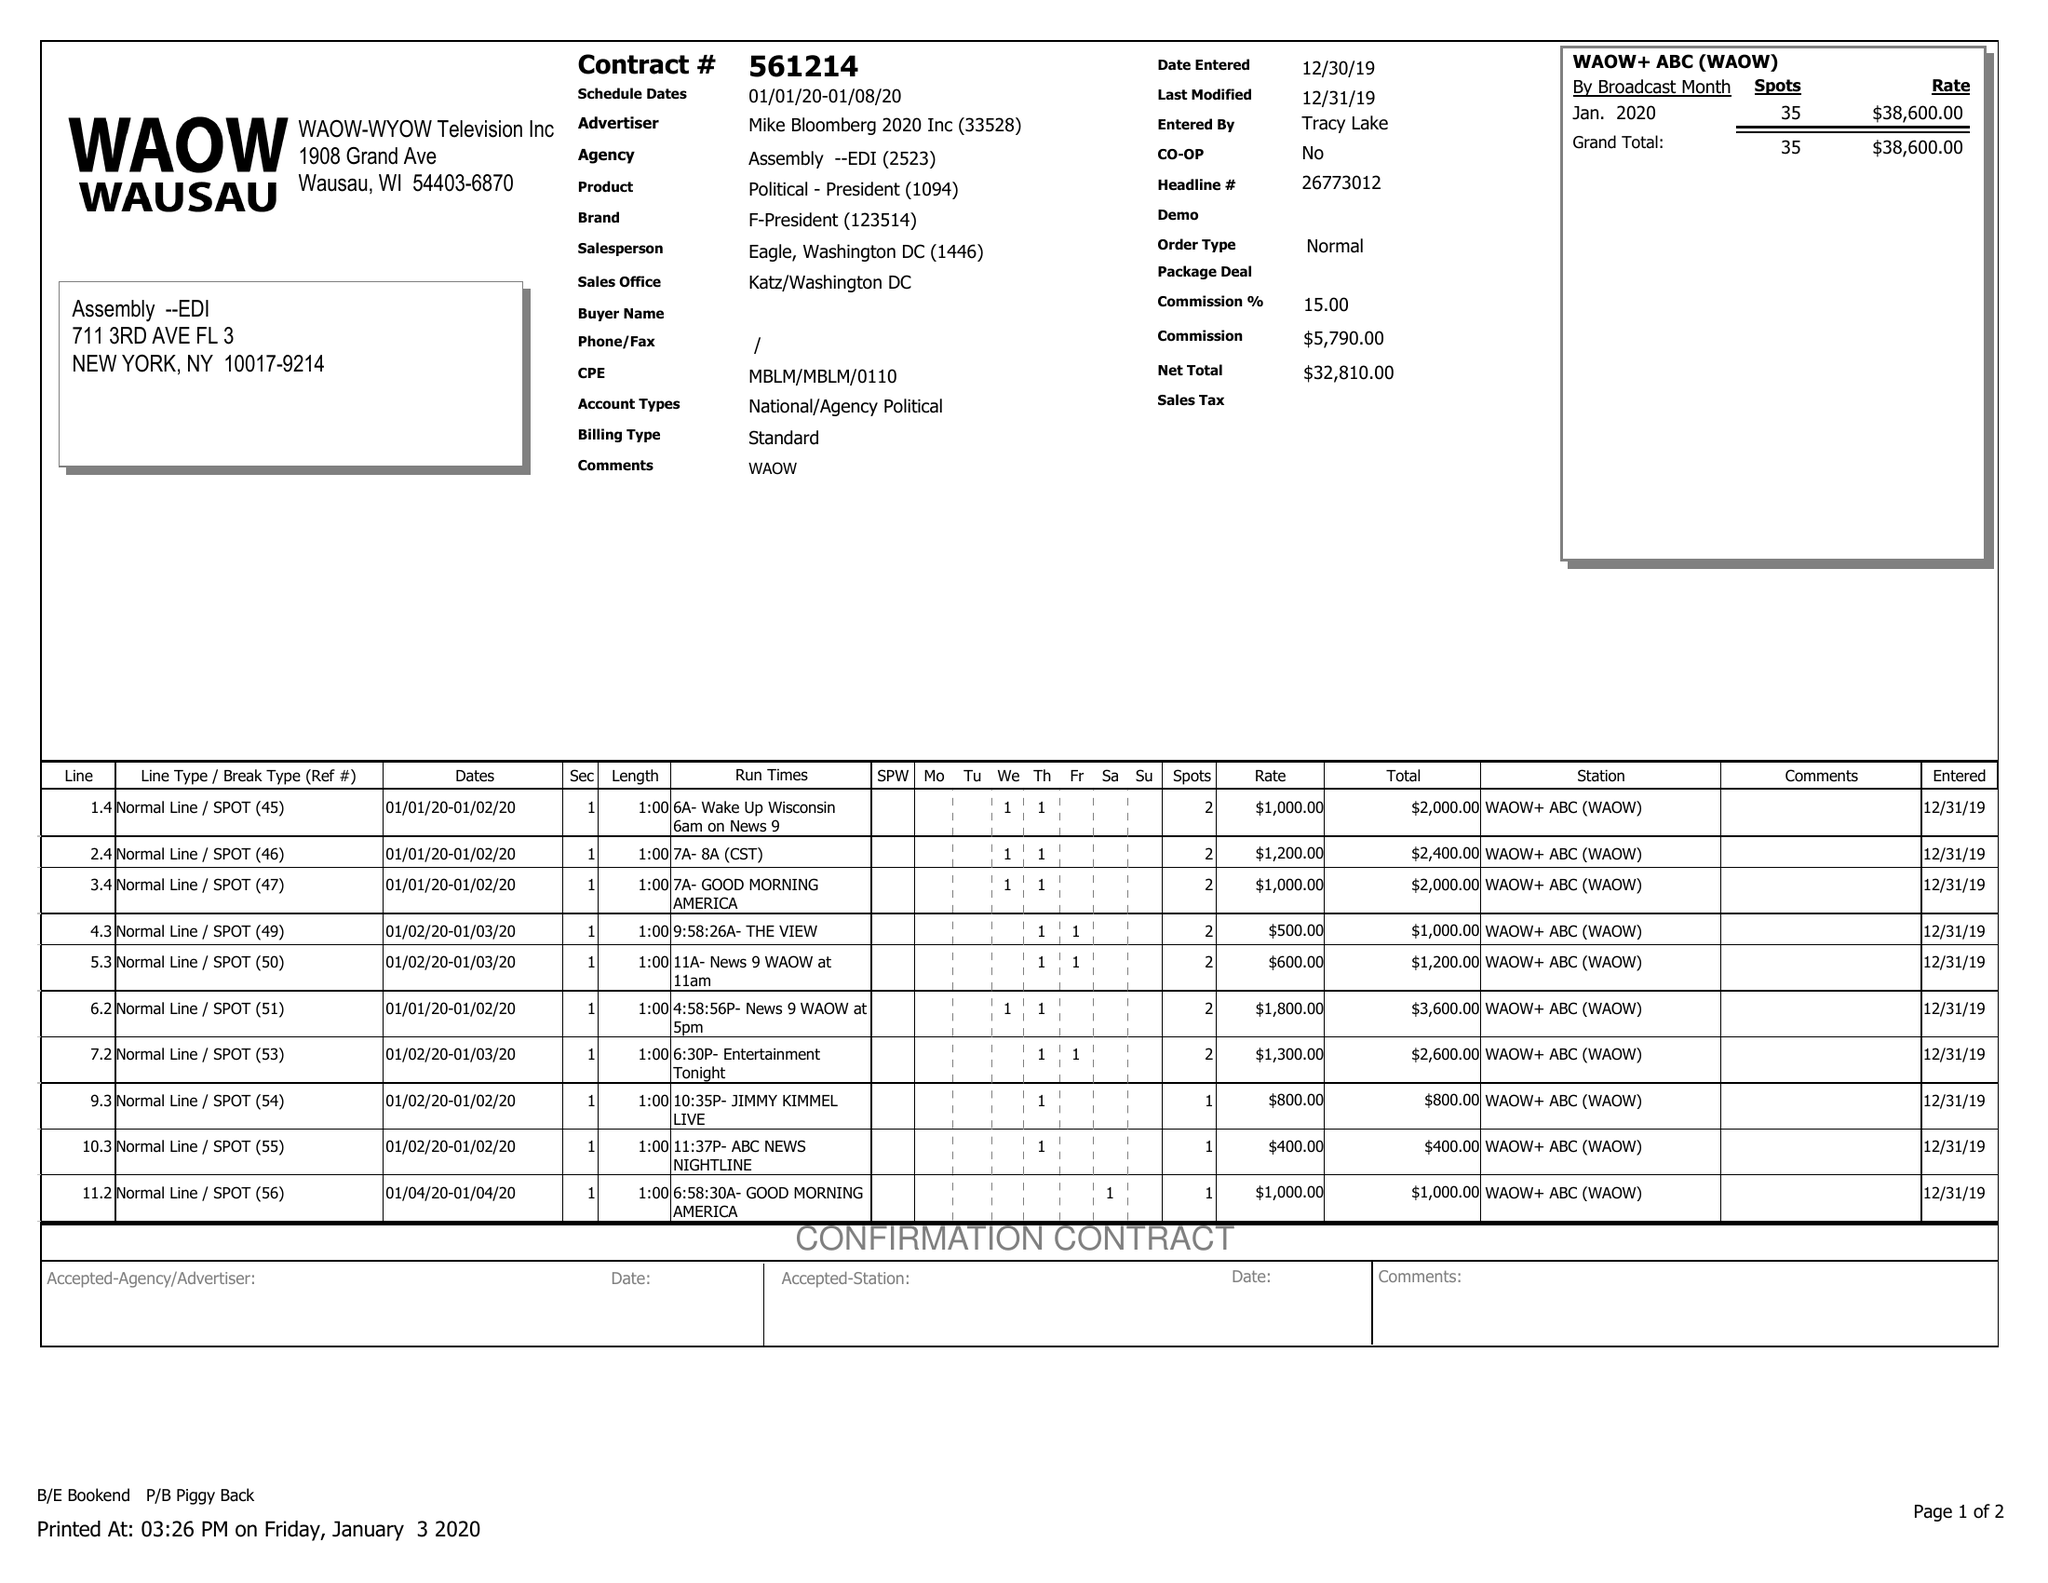What is the value for the flight_to?
Answer the question using a single word or phrase. 01/08/20 